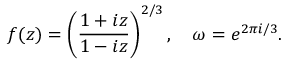<formula> <loc_0><loc_0><loc_500><loc_500>f ( z ) = \left ( \frac { 1 + i z } { 1 - i z } \right ) ^ { 2 / 3 } , \quad \omega = e ^ { 2 \pi i / 3 } .</formula> 